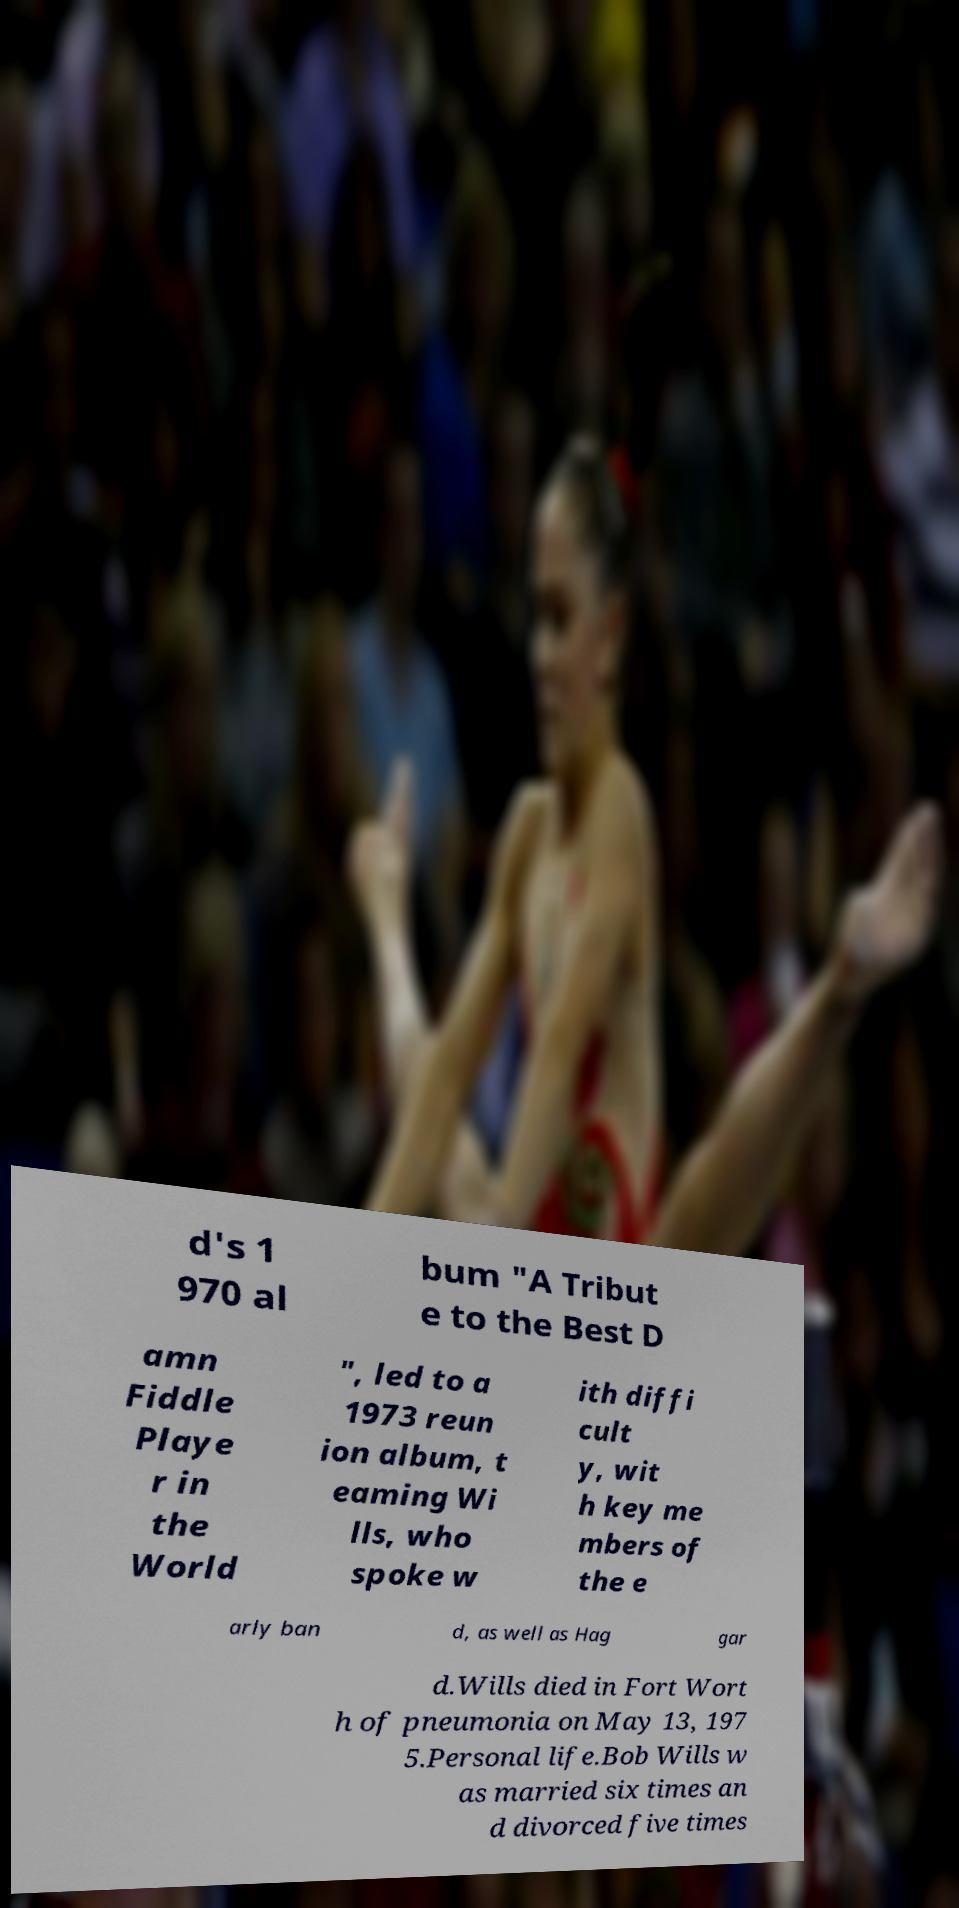I need the written content from this picture converted into text. Can you do that? d's 1 970 al bum "A Tribut e to the Best D amn Fiddle Playe r in the World ", led to a 1973 reun ion album, t eaming Wi lls, who spoke w ith diffi cult y, wit h key me mbers of the e arly ban d, as well as Hag gar d.Wills died in Fort Wort h of pneumonia on May 13, 197 5.Personal life.Bob Wills w as married six times an d divorced five times 